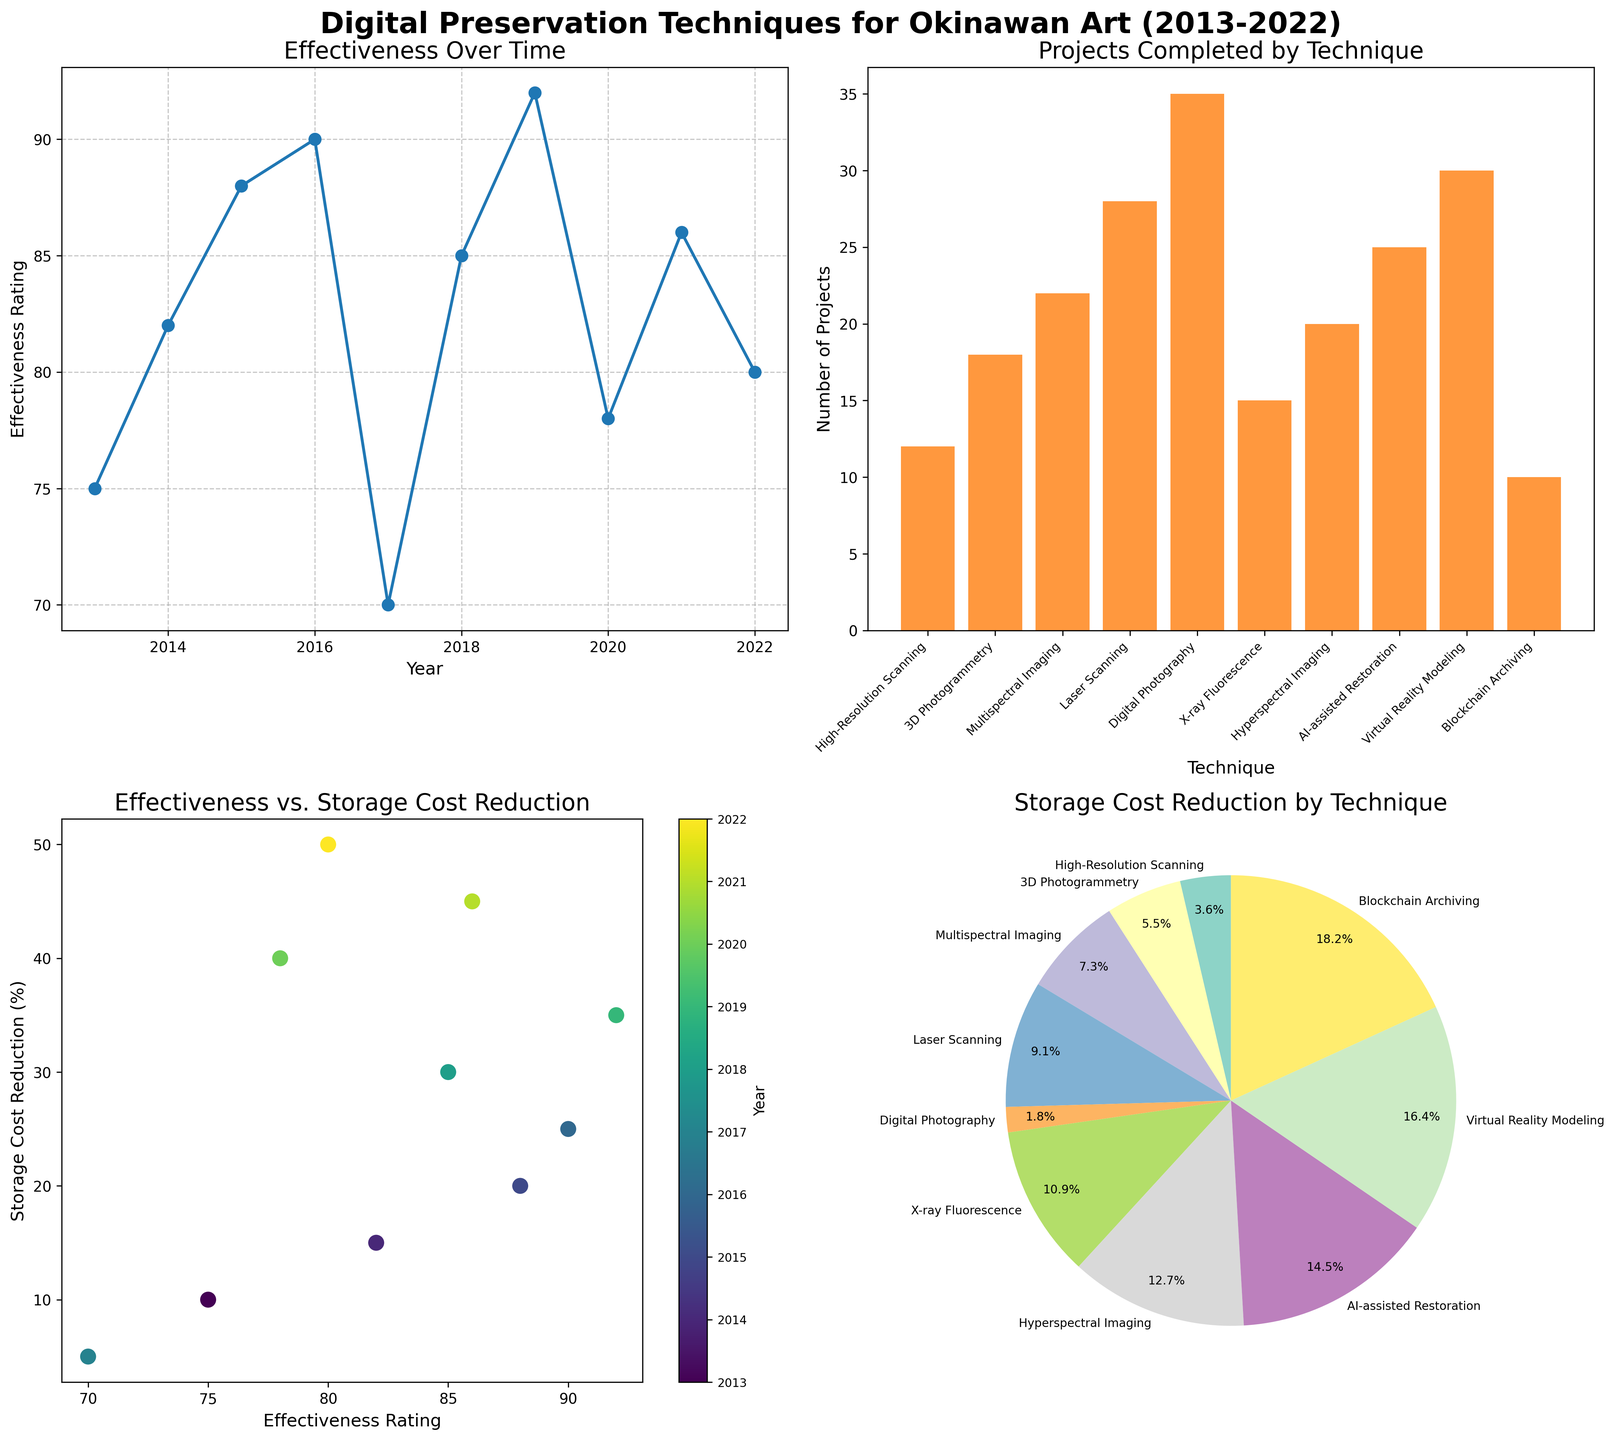What is the title of the line plot? The title of the line plot is found above the line chart, and it is written in larger, bold text.
Answer: Effectiveness Over Time How many techniques are displayed in the bar plot? Counting the number of bars in the bar plot will give the number of techniques displayed. Each bar represents a different technique.
Answer: 10 Which technique had the highest number of projects completed? By looking at the heights of the bars in the bar plot, the tallest bar corresponds to the technique with the highest number of projects completed.
Answer: Digital Photography What is the overall trend of the effectiveness rating over the years? Observing the line plot, the general direction of the line helps identify whether the effectiveness rating increases, decreases, or remains constant over the years.
Answer: Increasing Which year showed the highest storage cost reduction in the scatter plot? Look at the color legend and the point farthest to the right in the scatter plot. The corresponding year indicates the highest storage cost reduction.
Answer: 2022 What percentage of storage cost reduction is attributed to Blockchain Archiving according to the pie chart? Find the slice of the pie chart labeled "Blockchain Archiving" and look at the percentage written on it.
Answer: 50% How do 3D Photogrammetry and Hyperspectral Imaging compare in terms of effectiveness and storage cost reduction? Refer to both the line plot for effectiveness and the scatter plot for storage cost reduction data points for these two techniques.
Answer: 3D Photogrammetry has lower effectiveness (82) than Hyperspectral Imaging (92) and lower storage cost reduction (15% vs 35%) What is the average effectiveness rating of all techniques over the given years? Sum the effectiveness ratings of all techniques and divide by the number of techniques. (75+82+88+90+70+85+92+78+86+80)/10 = 82.6
Answer: 82.6 Which two techniques are closest in effectiveness rating, and what are those ratings? By comparing the effectiveness ratings in the line plot, identify the two techniques with the smallest difference in ratings.
Answer: AI-assisted Restoration (78) and Blockchain Archiving (80) What is the relationship shown between effectiveness and storage cost reduction in the scatter plot? Analyze the overall pattern of the data points in the scatter plot to infer if there's a positive or negative relationship.
Answer: Positive Relationship 